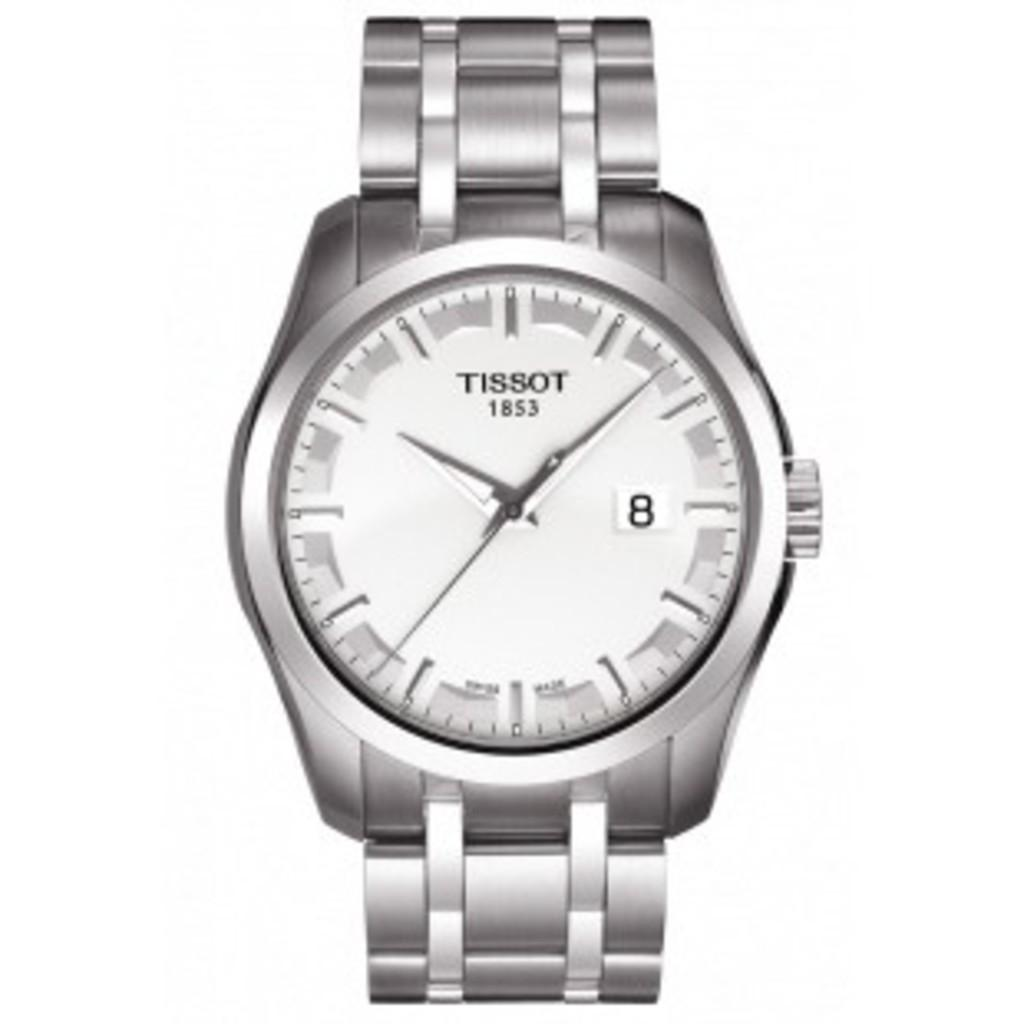<image>
Give a short and clear explanation of the subsequent image. A silver watch with the name Tissot on in and set to the time of 10:08. 